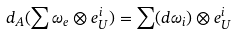<formula> <loc_0><loc_0><loc_500><loc_500>d _ { A } ( \sum \omega _ { e } \otimes e _ { U } ^ { i } ) = \sum ( d \omega _ { i } ) \otimes e _ { U } ^ { i }</formula> 